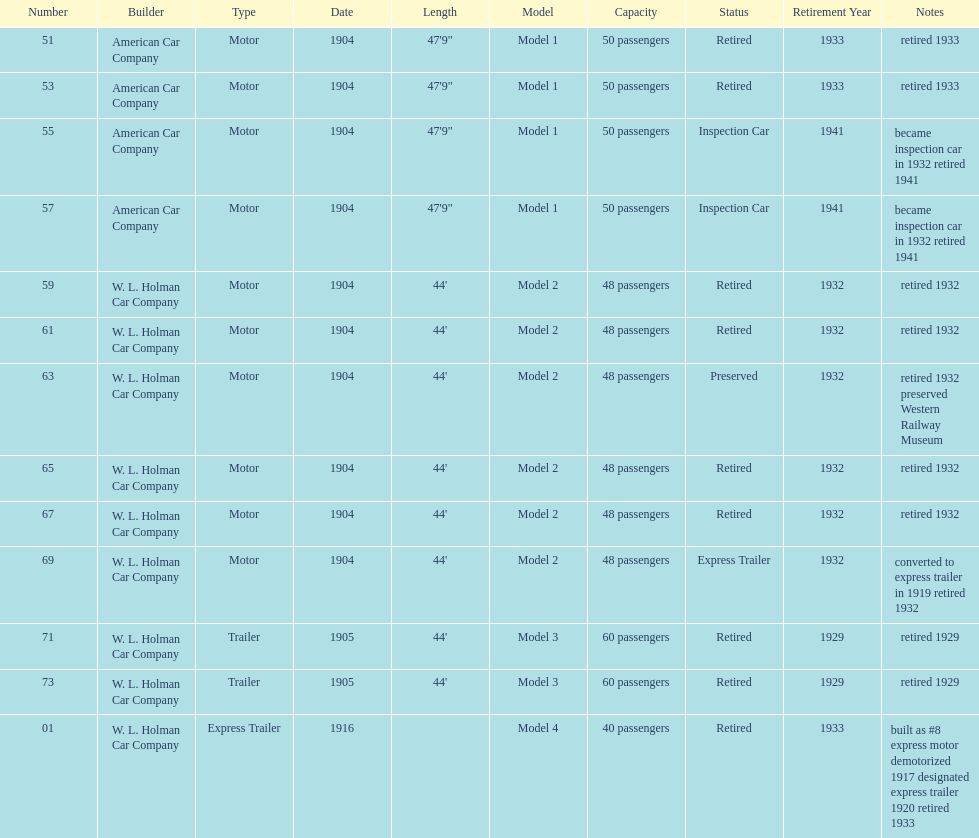Did american car company or w.l. holman car company build cars that were 44' in length? W. L. Holman Car Company. 